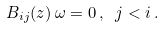<formula> <loc_0><loc_0><loc_500><loc_500>B _ { i j } ( z ) \, \omega = 0 \, , \ j < i \, .</formula> 